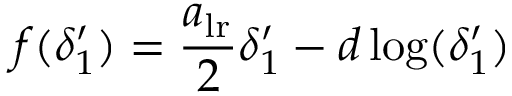Convert formula to latex. <formula><loc_0><loc_0><loc_500><loc_500>f ( \delta _ { 1 } ^ { \prime } ) = \frac { a _ { l r } } { 2 } \delta _ { 1 } ^ { \prime } - d \log ( \delta _ { 1 } ^ { \prime } )</formula> 